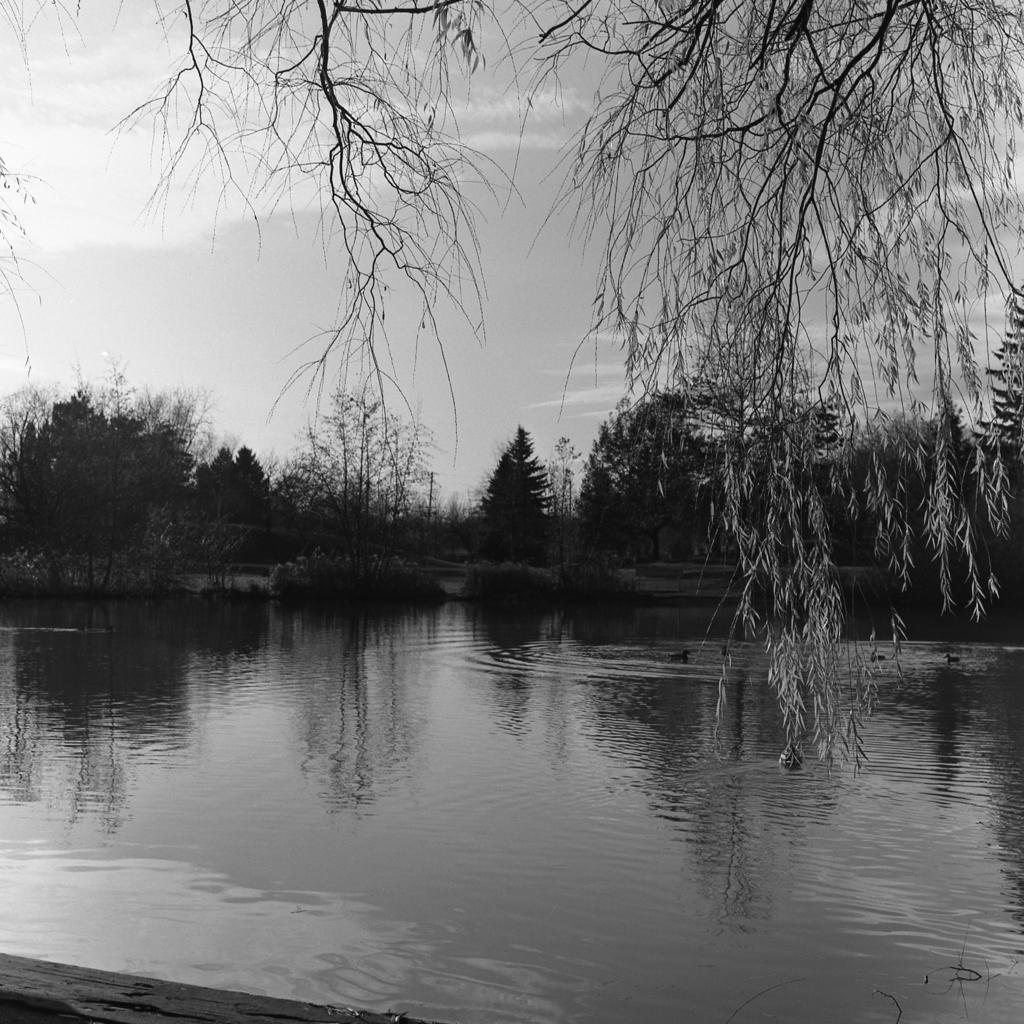What type of vegetation can be seen in the image? There are trees in the image. What natural element is visible in the image besides the trees? There is water visible in the image. What part of the natural environment is visible in the image? The sky is visible in the image. Can you see any fairies flying around the trees in the image? There are no fairies present in the image; it features trees, water, and the sky. Is there an island visible in the water in the image? There is no island present in the image; it only features trees, water, and the sky. 